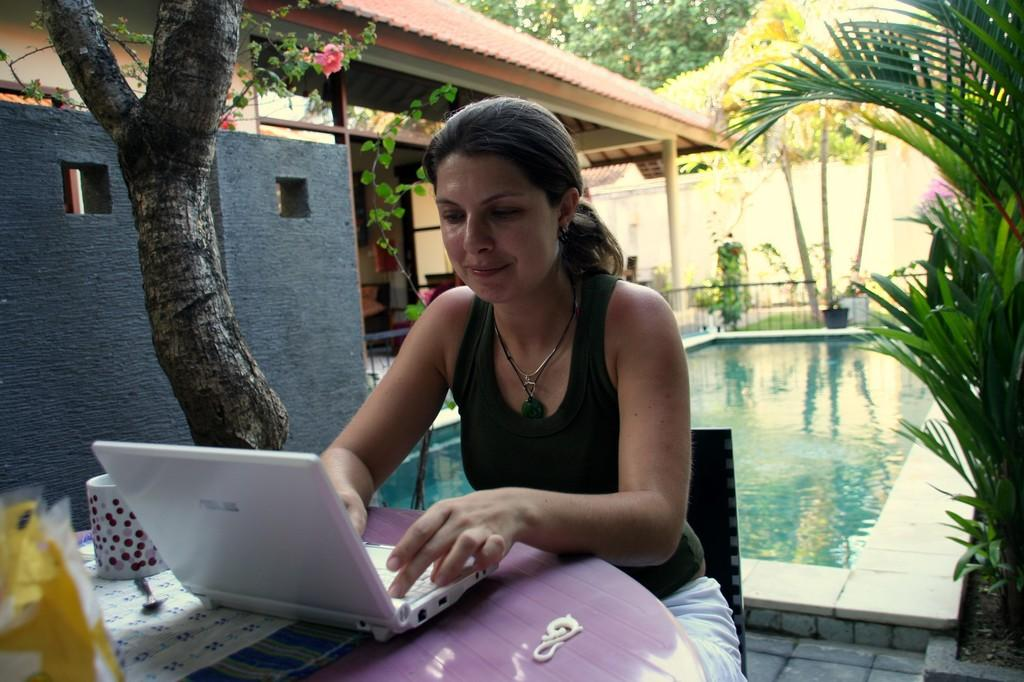Who is the main subject in the image? There is a woman in the image. What is the woman doing in the image? The woman is sitting in a chair and operating a laptop. Where is the laptop located in the image? The laptop is on a table. What other objects or structures can be seen in the image? There is a tree, a building, and a swimming pool in the image. What book is the woman reading at the party in the image? There is no book or party present in the image. The woman is operating a laptop, not reading a book. 